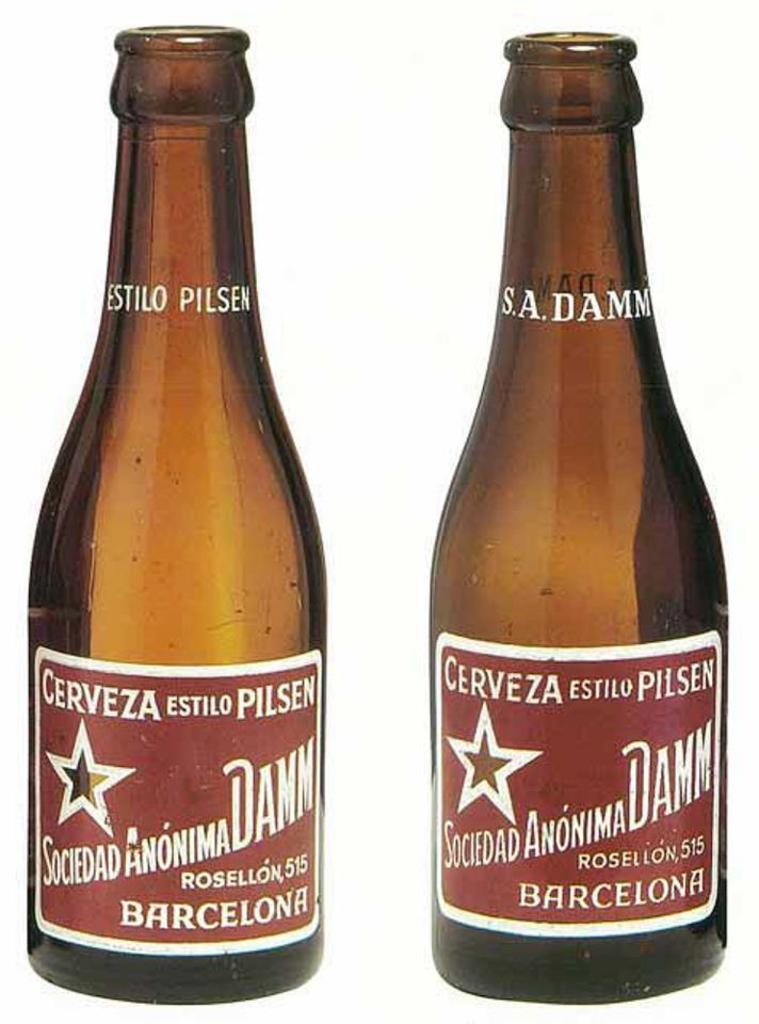<image>
Relay a brief, clear account of the picture shown. Two beer bottles with a red label identifying them as Cerveza Estilo Pilsen, Sociedad Anonima Damm. 